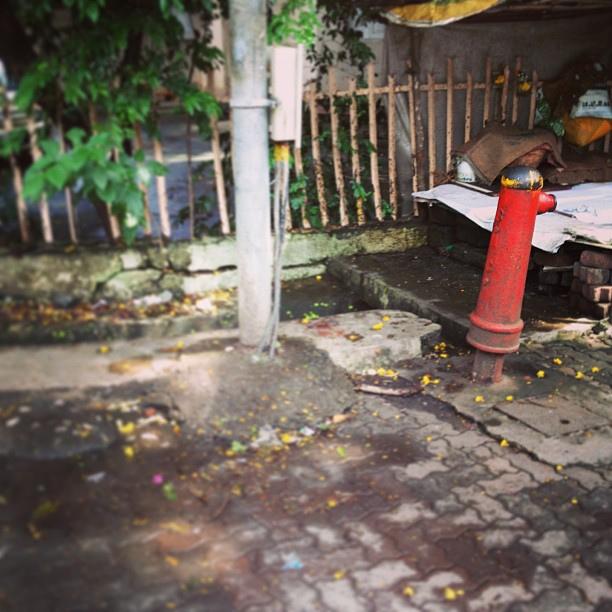Does that look like an effective fence?
Concise answer only. No. Is the ground wet?
Short answer required. Yes. Where is the fire hydrant?
Give a very brief answer. To right. 